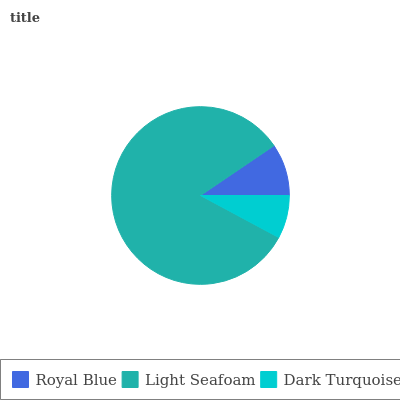Is Dark Turquoise the minimum?
Answer yes or no. Yes. Is Light Seafoam the maximum?
Answer yes or no. Yes. Is Light Seafoam the minimum?
Answer yes or no. No. Is Dark Turquoise the maximum?
Answer yes or no. No. Is Light Seafoam greater than Dark Turquoise?
Answer yes or no. Yes. Is Dark Turquoise less than Light Seafoam?
Answer yes or no. Yes. Is Dark Turquoise greater than Light Seafoam?
Answer yes or no. No. Is Light Seafoam less than Dark Turquoise?
Answer yes or no. No. Is Royal Blue the high median?
Answer yes or no. Yes. Is Royal Blue the low median?
Answer yes or no. Yes. Is Light Seafoam the high median?
Answer yes or no. No. Is Dark Turquoise the low median?
Answer yes or no. No. 